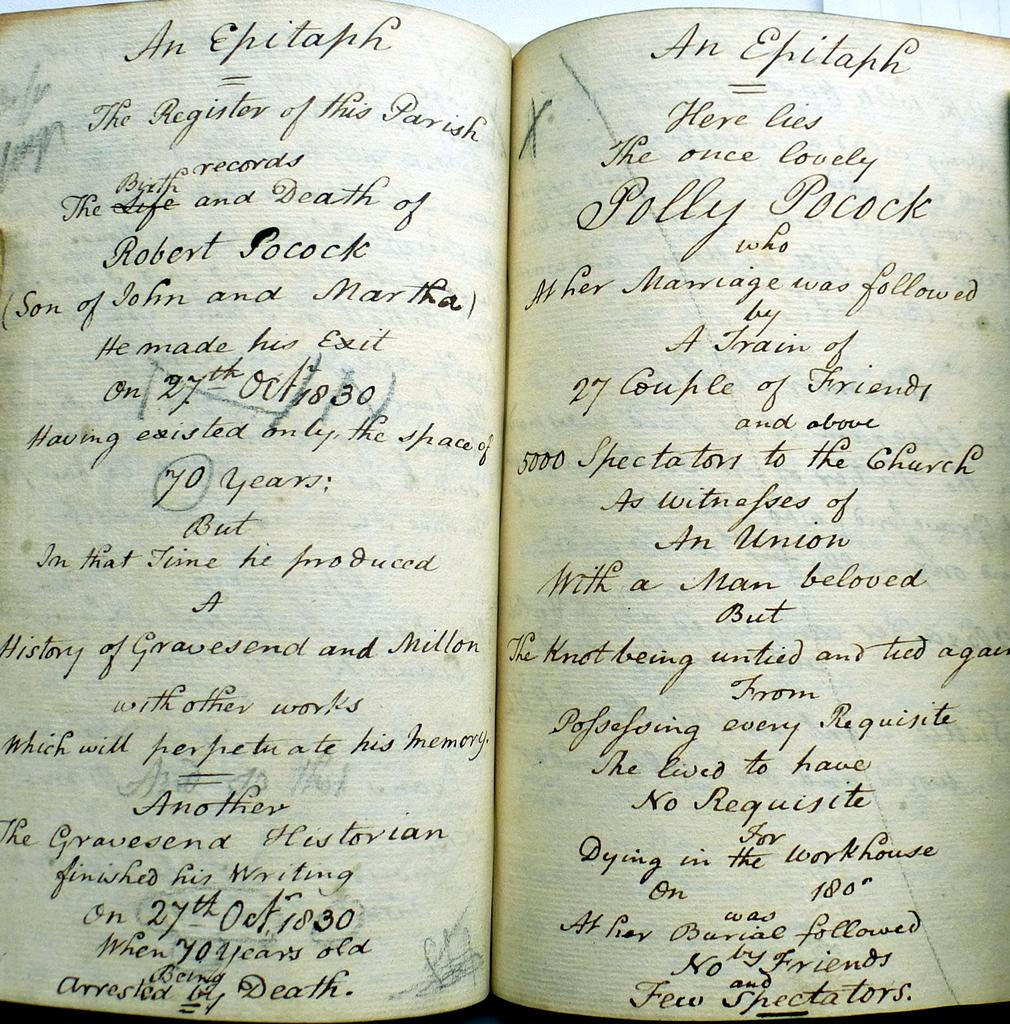<image>
Present a compact description of the photo's key features. an open copy of the book titled the epitaph. 